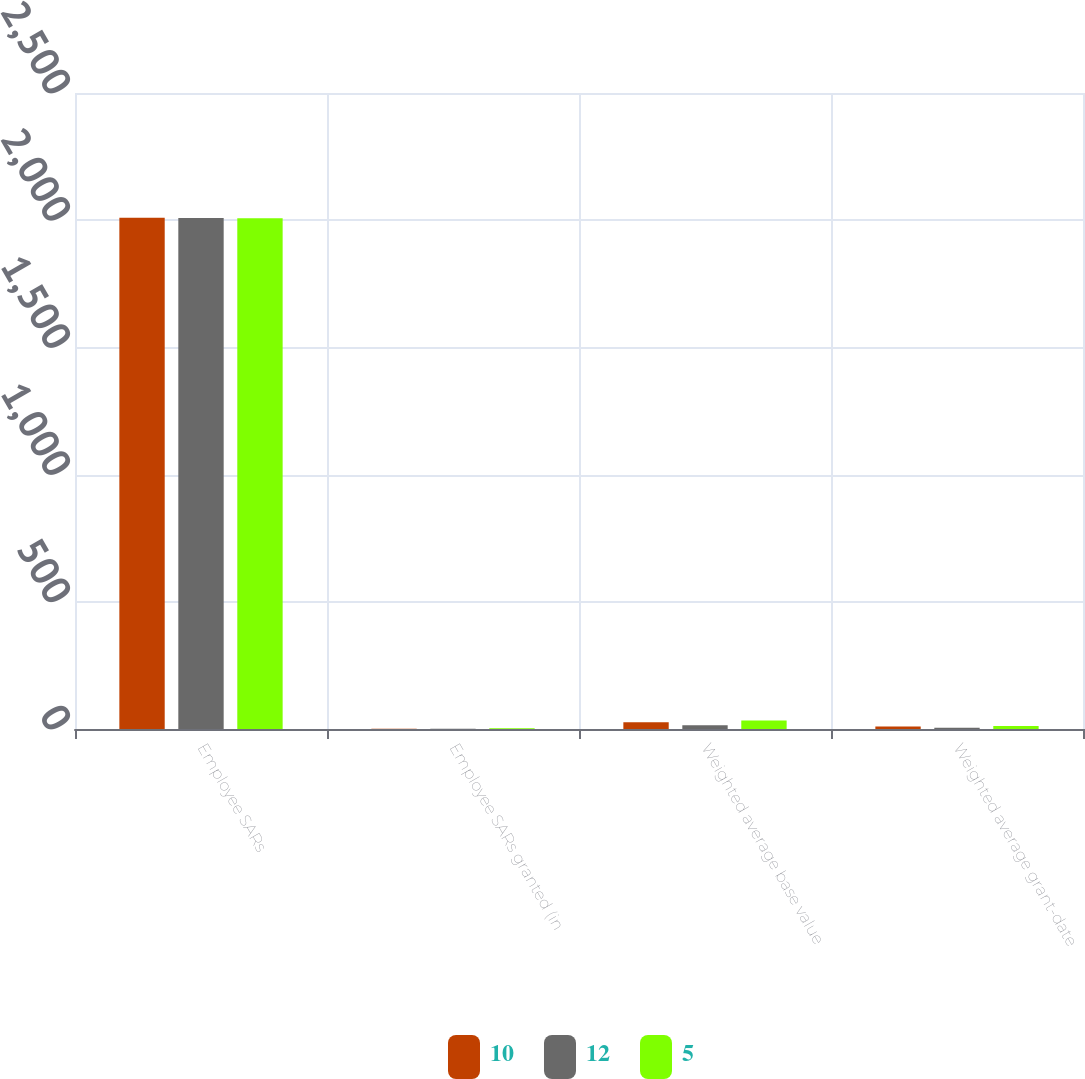Convert chart. <chart><loc_0><loc_0><loc_500><loc_500><stacked_bar_chart><ecel><fcel>Employee SARs<fcel>Employee SARs granted (in<fcel>Weighted average base value<fcel>Weighted average grant-date<nl><fcel>10<fcel>2010<fcel>1.1<fcel>27<fcel>10<nl><fcel>12<fcel>2009<fcel>0.5<fcel>15<fcel>5<nl><fcel>5<fcel>2008<fcel>2.7<fcel>33<fcel>12<nl></chart> 